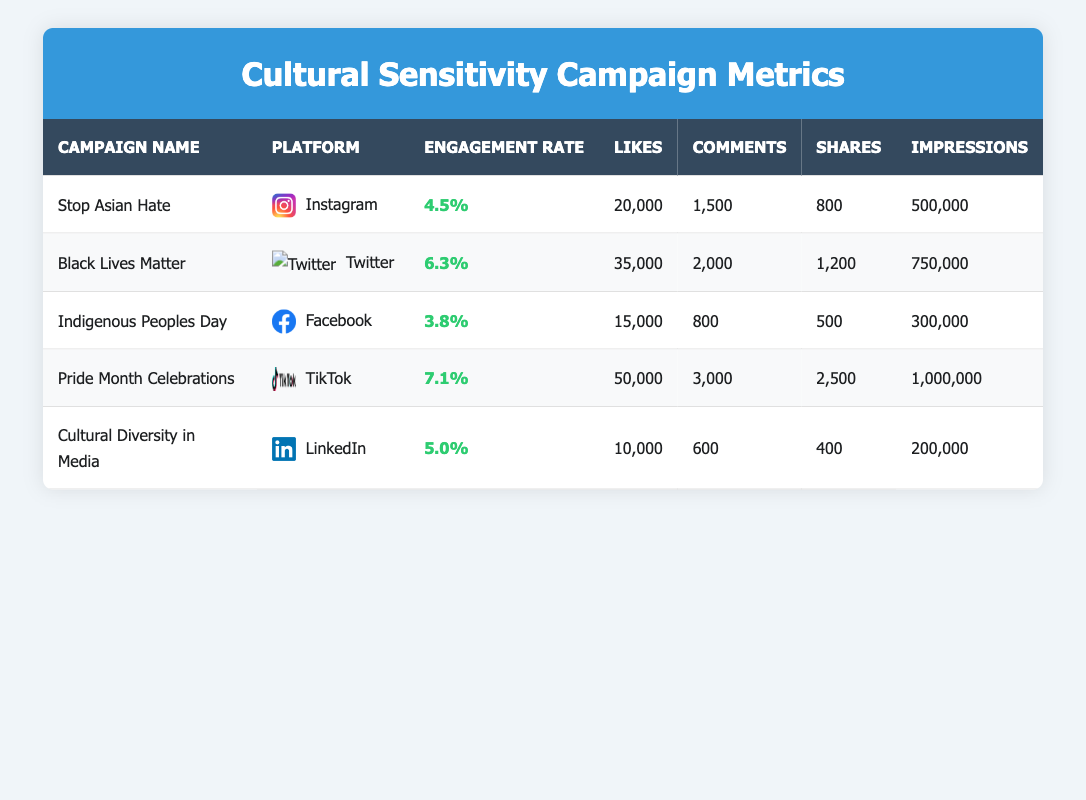What is the engagement rate for the "Pride Month Celebrations" campaign? The table lists "Pride Month Celebrations" under the campaign name, with its corresponding engagement rate shown as 7.1%.
Answer: 7.1% Which campaign received the highest number of likes? Looking through the likes column, "Pride Month Celebrations" has the highest count at 50,000 likes.
Answer: 50,000 Is the engagement rate for the "Stop Asian Hate" campaign greater than 4%? The engagement rate for "Stop Asian Hate" is 4.5%, which is indeed higher than 4%.
Answer: Yes What is the total number of shares across all campaigns on the table? Summing the shares from each campaign: 800 (Stop Asian Hate) + 1200 (Black Lives Matter) + 500 (Indigenous Peoples Day) + 2500 (Pride Month Celebrations) + 400 (Cultural Diversity in Media) = 4400.
Answer: 4400 Which platform had the lowest engagement rate and what was that rate? The "Indigenous Peoples Day" campaign on Facebook has the lowest engagement rate at 3.8%.
Answer: 3.8% What is the average number of comments across all campaigns? Total comments: 1500 (Stop Asian Hate) + 2000 (Black Lives Matter) + 800 (Indigenous Peoples Day) + 3000 (Pride Month Celebrations) + 600 (Cultural Diversity in Media) = 8500. Dividing by 5 gives the average: 8500 / 5 = 1700.
Answer: 1700 Is the number of impressions for the "Cultural Diversity in Media" campaign less than 300,000? The impressions for "Cultural Diversity in Media" are shown as 200,000, which is indeed less than 300,000.
Answer: Yes How does the engagement rate of the "Black Lives Matter" campaign compare to the average engagement rate of all campaigns in the table? The engagement rates are 4.5%, 6.3%, 3.8%, 7.1%, and 5.0%. The average is calculated as (4.5 + 6.3 + 3.8 + 7.1 + 5.0) / 5 = 5.34. Since 6.3% is greater than 5.34%, the answer is yes.
Answer: Yes Which campaign on Twitter has more likes: "Black Lives Matter" or "Stop Asian Hate"? "Black Lives Matter" has 35,000 likes while "Stop Asian Hate" has 20,000 likes. Therefore, "Black Lives Matter" has more likes than "Stop Asian Hate".
Answer: Black Lives Matter 